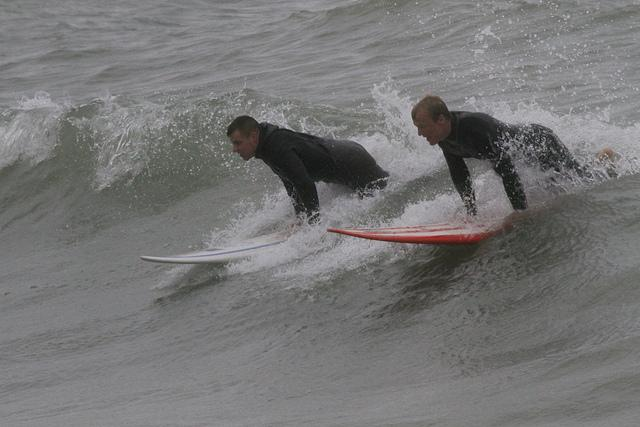What are the men on the boards attempting to do? Please explain your reasoning. stand. They are both trying to stand on the surfboards. 